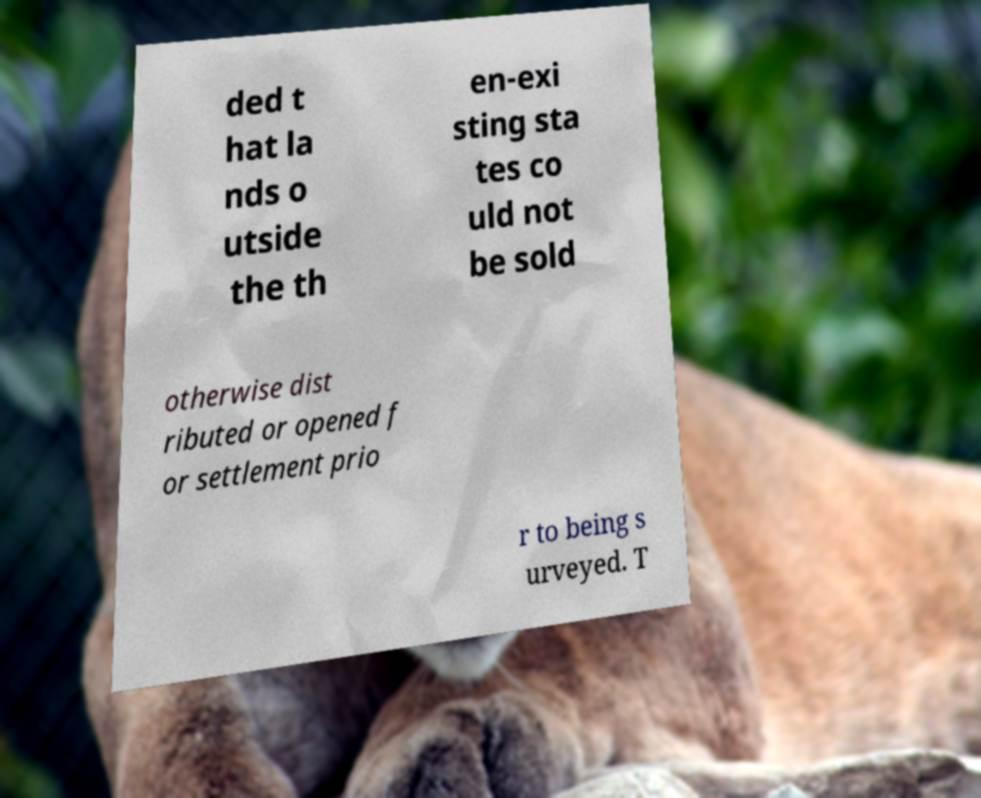Could you assist in decoding the text presented in this image and type it out clearly? ded t hat la nds o utside the th en-exi sting sta tes co uld not be sold otherwise dist ributed or opened f or settlement prio r to being s urveyed. T 